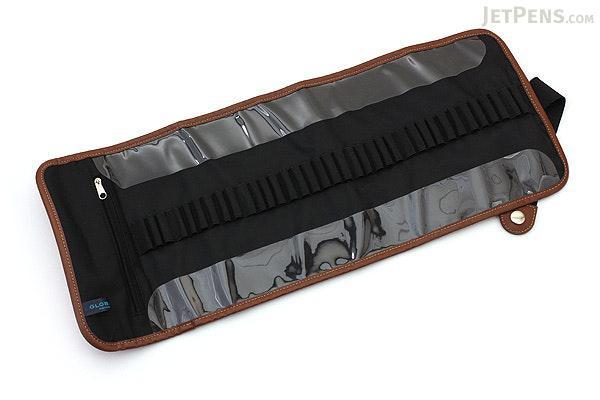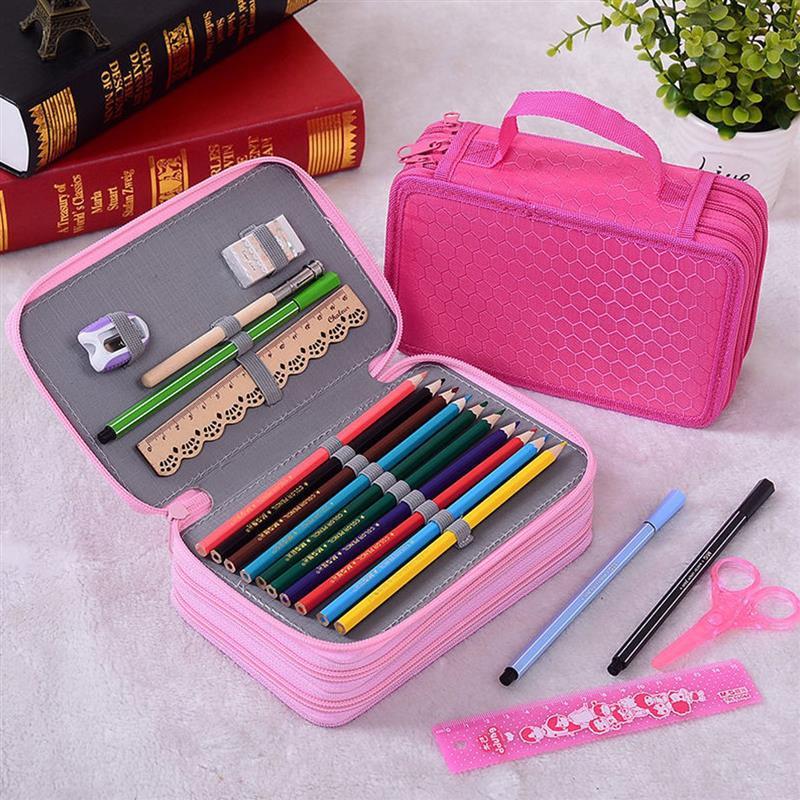The first image is the image on the left, the second image is the image on the right. For the images displayed, is the sentence "Two pink pencil cases sit next to each other in the image on the right." factually correct? Answer yes or no. Yes. The first image is the image on the left, the second image is the image on the right. Assess this claim about the two images: "One image includes an opened pink case filled with writing implements.". Correct or not? Answer yes or no. Yes. 